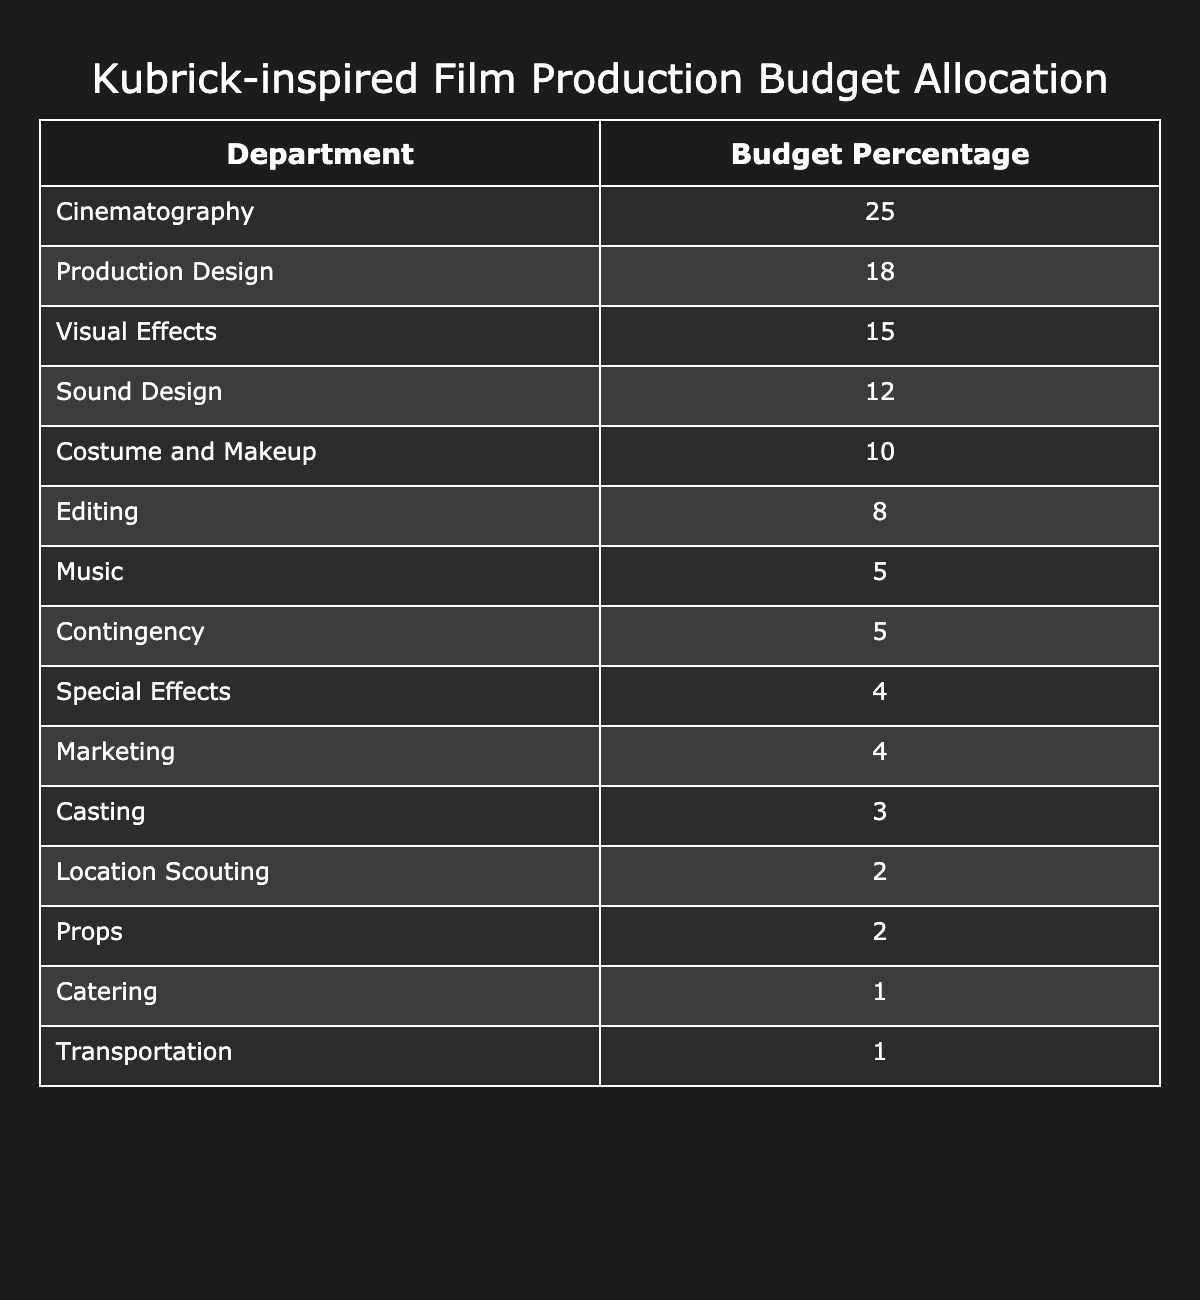What is the budget percentage allocated to Cinematography? The table clearly shows that Cinematography has a budget percentage of 25%.
Answer: 25 Which department has the lowest budget allocation? According to the table, both Catering and Transportation share the lowest budget allocations at 1%.
Answer: 1% What is the total budget percentage for Editing and Music combined? The budget percentage for Editing is 8% and for Music it is 5%. Adding these together: 8 + 5 = 13.
Answer: 13 Is the budget allocation for Visual Effects greater than that for Sound Design? The table lists Visual Effects with a percentage of 15% and Sound Design with 12%. Since 15% is greater than 12%, the statement is true.
Answer: Yes What is the average budget percentage for the departments of Costume and Makeup, Sound Design, and Music? The budget percentages for these departments are 10%, 12%, and 5% respectively. The total is 10 + 12 + 5 = 27%, and there are 3 departments, so the average is 27 / 3 = 9.
Answer: 9 Which department receives a budget percentage greater than 10% but less than 20%? Looking at the table, Production Design has a budget percentage of 18%, which fits this criterion.
Answer: 18 How much more is allocated to Cinematography than to Costume and Makeup? Cinematography has 25% and Costume and Makeup has 10%. The difference is calculated as 25 - 10 = 15.
Answer: 15 What is the total budget percentage allocated to departments that deal with design (Cinematography, Production Design, and Visual Effects)? Adding the budget percentages for these departments: 25 (Cinematography) + 18 (Production Design) + 15 (Visual Effects) = 58%.
Answer: 58 Is the budget percentage for Casting more than that for Special Effects? The table shows Casting at 3% and Special Effects at 4%. Since 3% is less than 4%, the statement is false.
Answer: No What is the total budget percentage allocated to departments that have a budget percentage of 4% or less? The departments with 4% or less are Casting (3%), Location Scouting (2%), Props (2%), Catering (1%), and Transportation (1%). Summing these gives 3 + 2 + 2 + 1 + 1 = 9.
Answer: 9 